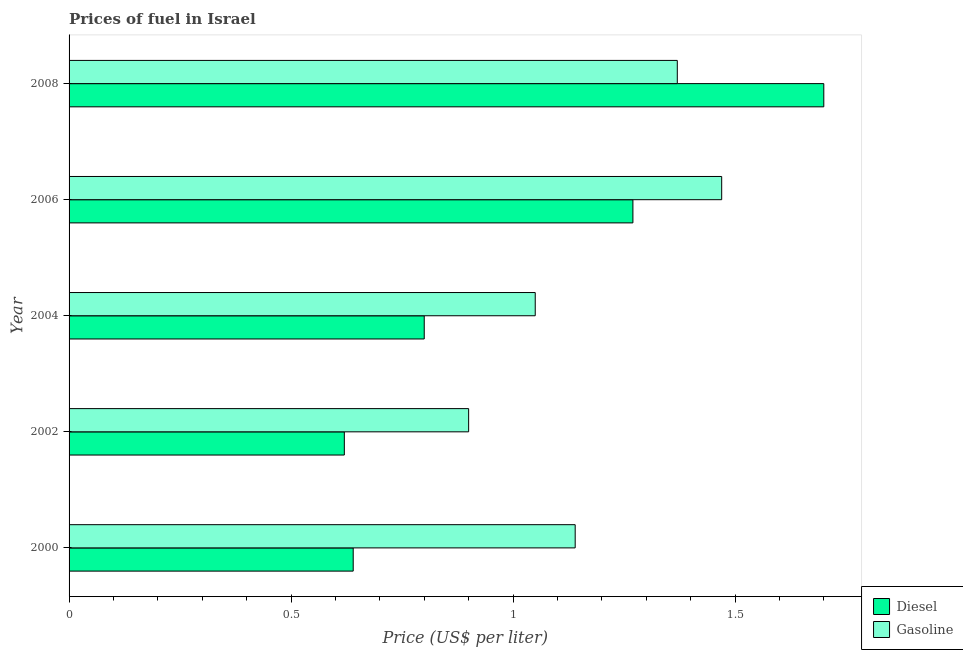How many groups of bars are there?
Your response must be concise. 5. How many bars are there on the 5th tick from the bottom?
Provide a short and direct response. 2. What is the gasoline price in 2000?
Provide a short and direct response. 1.14. In which year was the gasoline price maximum?
Give a very brief answer. 2006. In which year was the diesel price minimum?
Your answer should be very brief. 2002. What is the total diesel price in the graph?
Your response must be concise. 5.03. What is the difference between the diesel price in 2000 and that in 2008?
Offer a terse response. -1.06. What is the difference between the gasoline price in 2006 and the diesel price in 2004?
Ensure brevity in your answer.  0.67. What is the average diesel price per year?
Ensure brevity in your answer.  1.01. In the year 2004, what is the difference between the diesel price and gasoline price?
Provide a short and direct response. -0.25. What is the ratio of the gasoline price in 2000 to that in 2002?
Your response must be concise. 1.27. What does the 2nd bar from the top in 2006 represents?
Make the answer very short. Diesel. What does the 1st bar from the bottom in 2000 represents?
Keep it short and to the point. Diesel. Are all the bars in the graph horizontal?
Offer a terse response. Yes. What is the difference between two consecutive major ticks on the X-axis?
Provide a succinct answer. 0.5. Are the values on the major ticks of X-axis written in scientific E-notation?
Your answer should be compact. No. Does the graph contain grids?
Your response must be concise. No. What is the title of the graph?
Your answer should be compact. Prices of fuel in Israel. What is the label or title of the X-axis?
Offer a very short reply. Price (US$ per liter). What is the Price (US$ per liter) of Diesel in 2000?
Provide a short and direct response. 0.64. What is the Price (US$ per liter) in Gasoline in 2000?
Provide a short and direct response. 1.14. What is the Price (US$ per liter) in Diesel in 2002?
Your response must be concise. 0.62. What is the Price (US$ per liter) of Diesel in 2004?
Give a very brief answer. 0.8. What is the Price (US$ per liter) in Diesel in 2006?
Keep it short and to the point. 1.27. What is the Price (US$ per liter) of Gasoline in 2006?
Keep it short and to the point. 1.47. What is the Price (US$ per liter) of Gasoline in 2008?
Provide a short and direct response. 1.37. Across all years, what is the maximum Price (US$ per liter) in Diesel?
Ensure brevity in your answer.  1.7. Across all years, what is the maximum Price (US$ per liter) in Gasoline?
Your response must be concise. 1.47. Across all years, what is the minimum Price (US$ per liter) of Diesel?
Ensure brevity in your answer.  0.62. Across all years, what is the minimum Price (US$ per liter) of Gasoline?
Give a very brief answer. 0.9. What is the total Price (US$ per liter) of Diesel in the graph?
Offer a terse response. 5.03. What is the total Price (US$ per liter) in Gasoline in the graph?
Your answer should be compact. 5.93. What is the difference between the Price (US$ per liter) of Gasoline in 2000 and that in 2002?
Your response must be concise. 0.24. What is the difference between the Price (US$ per liter) in Diesel in 2000 and that in 2004?
Provide a succinct answer. -0.16. What is the difference between the Price (US$ per liter) in Gasoline in 2000 and that in 2004?
Make the answer very short. 0.09. What is the difference between the Price (US$ per liter) of Diesel in 2000 and that in 2006?
Offer a very short reply. -0.63. What is the difference between the Price (US$ per liter) of Gasoline in 2000 and that in 2006?
Make the answer very short. -0.33. What is the difference between the Price (US$ per liter) in Diesel in 2000 and that in 2008?
Ensure brevity in your answer.  -1.06. What is the difference between the Price (US$ per liter) in Gasoline in 2000 and that in 2008?
Provide a succinct answer. -0.23. What is the difference between the Price (US$ per liter) in Diesel in 2002 and that in 2004?
Your answer should be compact. -0.18. What is the difference between the Price (US$ per liter) in Diesel in 2002 and that in 2006?
Offer a very short reply. -0.65. What is the difference between the Price (US$ per liter) in Gasoline in 2002 and that in 2006?
Your response must be concise. -0.57. What is the difference between the Price (US$ per liter) of Diesel in 2002 and that in 2008?
Provide a succinct answer. -1.08. What is the difference between the Price (US$ per liter) in Gasoline in 2002 and that in 2008?
Offer a very short reply. -0.47. What is the difference between the Price (US$ per liter) of Diesel in 2004 and that in 2006?
Offer a terse response. -0.47. What is the difference between the Price (US$ per liter) of Gasoline in 2004 and that in 2006?
Your response must be concise. -0.42. What is the difference between the Price (US$ per liter) of Diesel in 2004 and that in 2008?
Your answer should be very brief. -0.9. What is the difference between the Price (US$ per liter) of Gasoline in 2004 and that in 2008?
Your answer should be very brief. -0.32. What is the difference between the Price (US$ per liter) in Diesel in 2006 and that in 2008?
Your answer should be very brief. -0.43. What is the difference between the Price (US$ per liter) in Gasoline in 2006 and that in 2008?
Give a very brief answer. 0.1. What is the difference between the Price (US$ per liter) in Diesel in 2000 and the Price (US$ per liter) in Gasoline in 2002?
Make the answer very short. -0.26. What is the difference between the Price (US$ per liter) of Diesel in 2000 and the Price (US$ per liter) of Gasoline in 2004?
Provide a short and direct response. -0.41. What is the difference between the Price (US$ per liter) in Diesel in 2000 and the Price (US$ per liter) in Gasoline in 2006?
Provide a succinct answer. -0.83. What is the difference between the Price (US$ per liter) of Diesel in 2000 and the Price (US$ per liter) of Gasoline in 2008?
Keep it short and to the point. -0.73. What is the difference between the Price (US$ per liter) in Diesel in 2002 and the Price (US$ per liter) in Gasoline in 2004?
Your answer should be very brief. -0.43. What is the difference between the Price (US$ per liter) in Diesel in 2002 and the Price (US$ per liter) in Gasoline in 2006?
Your answer should be very brief. -0.85. What is the difference between the Price (US$ per liter) in Diesel in 2002 and the Price (US$ per liter) in Gasoline in 2008?
Ensure brevity in your answer.  -0.75. What is the difference between the Price (US$ per liter) of Diesel in 2004 and the Price (US$ per liter) of Gasoline in 2006?
Make the answer very short. -0.67. What is the difference between the Price (US$ per liter) in Diesel in 2004 and the Price (US$ per liter) in Gasoline in 2008?
Offer a very short reply. -0.57. What is the average Price (US$ per liter) in Diesel per year?
Provide a succinct answer. 1.01. What is the average Price (US$ per liter) in Gasoline per year?
Keep it short and to the point. 1.19. In the year 2000, what is the difference between the Price (US$ per liter) in Diesel and Price (US$ per liter) in Gasoline?
Make the answer very short. -0.5. In the year 2002, what is the difference between the Price (US$ per liter) in Diesel and Price (US$ per liter) in Gasoline?
Give a very brief answer. -0.28. In the year 2004, what is the difference between the Price (US$ per liter) of Diesel and Price (US$ per liter) of Gasoline?
Make the answer very short. -0.25. In the year 2006, what is the difference between the Price (US$ per liter) of Diesel and Price (US$ per liter) of Gasoline?
Keep it short and to the point. -0.2. In the year 2008, what is the difference between the Price (US$ per liter) in Diesel and Price (US$ per liter) in Gasoline?
Ensure brevity in your answer.  0.33. What is the ratio of the Price (US$ per liter) in Diesel in 2000 to that in 2002?
Ensure brevity in your answer.  1.03. What is the ratio of the Price (US$ per liter) in Gasoline in 2000 to that in 2002?
Give a very brief answer. 1.27. What is the ratio of the Price (US$ per liter) of Diesel in 2000 to that in 2004?
Make the answer very short. 0.8. What is the ratio of the Price (US$ per liter) of Gasoline in 2000 to that in 2004?
Make the answer very short. 1.09. What is the ratio of the Price (US$ per liter) of Diesel in 2000 to that in 2006?
Your answer should be compact. 0.5. What is the ratio of the Price (US$ per liter) in Gasoline in 2000 to that in 2006?
Ensure brevity in your answer.  0.78. What is the ratio of the Price (US$ per liter) in Diesel in 2000 to that in 2008?
Give a very brief answer. 0.38. What is the ratio of the Price (US$ per liter) in Gasoline in 2000 to that in 2008?
Keep it short and to the point. 0.83. What is the ratio of the Price (US$ per liter) in Diesel in 2002 to that in 2004?
Offer a very short reply. 0.78. What is the ratio of the Price (US$ per liter) in Gasoline in 2002 to that in 2004?
Provide a succinct answer. 0.86. What is the ratio of the Price (US$ per liter) of Diesel in 2002 to that in 2006?
Give a very brief answer. 0.49. What is the ratio of the Price (US$ per liter) in Gasoline in 2002 to that in 2006?
Offer a very short reply. 0.61. What is the ratio of the Price (US$ per liter) in Diesel in 2002 to that in 2008?
Give a very brief answer. 0.36. What is the ratio of the Price (US$ per liter) of Gasoline in 2002 to that in 2008?
Offer a very short reply. 0.66. What is the ratio of the Price (US$ per liter) in Diesel in 2004 to that in 2006?
Your answer should be very brief. 0.63. What is the ratio of the Price (US$ per liter) of Diesel in 2004 to that in 2008?
Provide a short and direct response. 0.47. What is the ratio of the Price (US$ per liter) of Gasoline in 2004 to that in 2008?
Offer a terse response. 0.77. What is the ratio of the Price (US$ per liter) of Diesel in 2006 to that in 2008?
Offer a terse response. 0.75. What is the ratio of the Price (US$ per liter) in Gasoline in 2006 to that in 2008?
Provide a succinct answer. 1.07. What is the difference between the highest and the second highest Price (US$ per liter) of Diesel?
Your answer should be very brief. 0.43. What is the difference between the highest and the lowest Price (US$ per liter) in Gasoline?
Give a very brief answer. 0.57. 